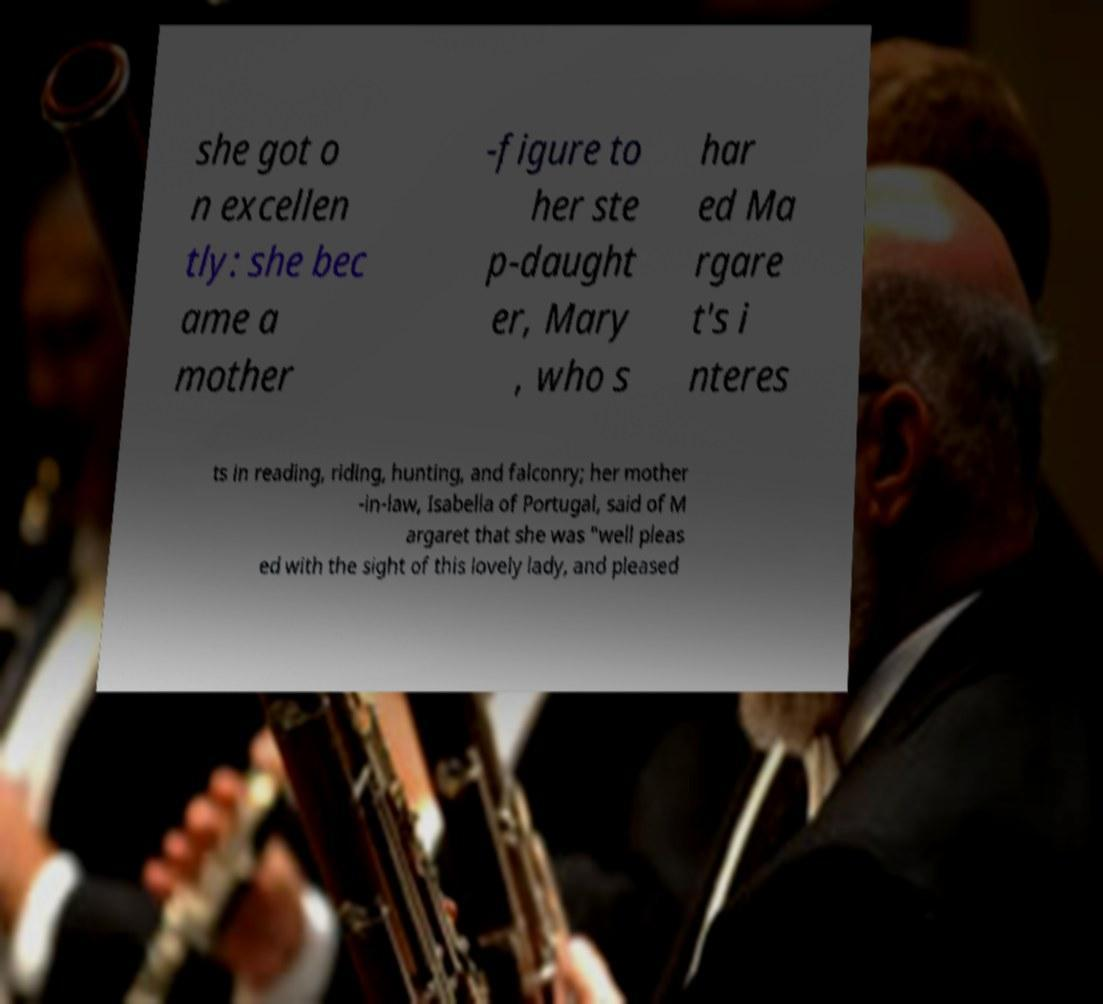There's text embedded in this image that I need extracted. Can you transcribe it verbatim? she got o n excellen tly: she bec ame a mother -figure to her ste p-daught er, Mary , who s har ed Ma rgare t's i nteres ts in reading, riding, hunting, and falconry; her mother -in-law, Isabella of Portugal, said of M argaret that she was "well pleas ed with the sight of this lovely lady, and pleased 